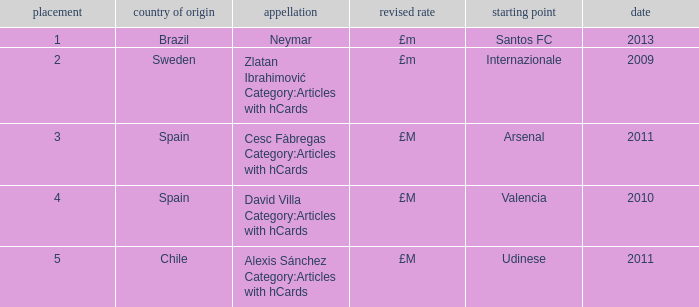What is the most recent year a player was from Valencia? 2010.0. 